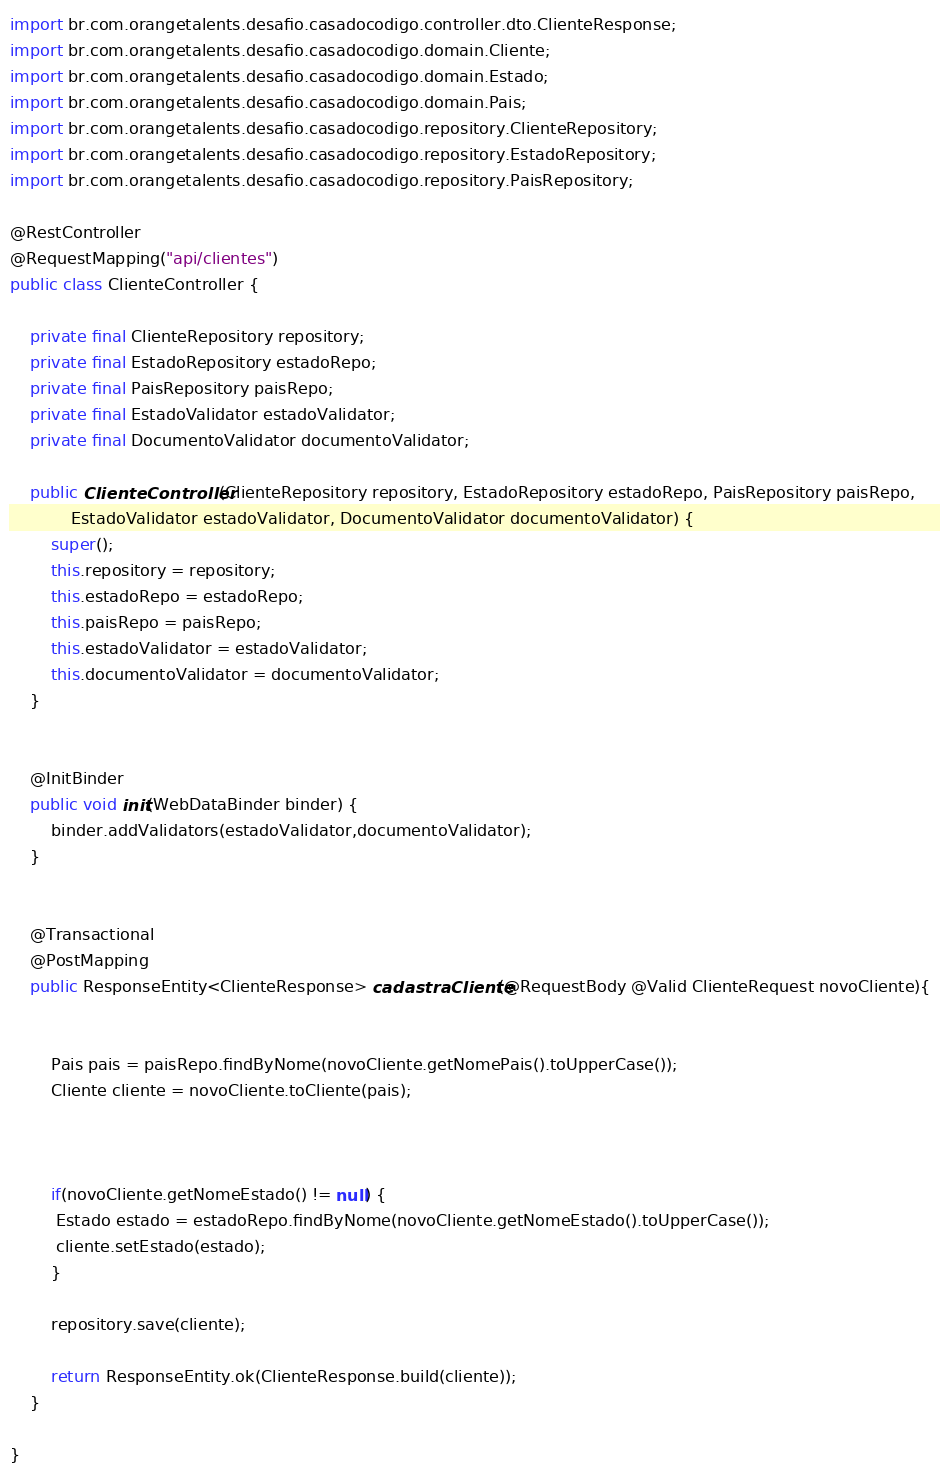<code> <loc_0><loc_0><loc_500><loc_500><_Java_>import br.com.orangetalents.desafio.casadocodigo.controller.dto.ClienteResponse;
import br.com.orangetalents.desafio.casadocodigo.domain.Cliente;
import br.com.orangetalents.desafio.casadocodigo.domain.Estado;
import br.com.orangetalents.desafio.casadocodigo.domain.Pais;
import br.com.orangetalents.desafio.casadocodigo.repository.ClienteRepository;
import br.com.orangetalents.desafio.casadocodigo.repository.EstadoRepository;
import br.com.orangetalents.desafio.casadocodigo.repository.PaisRepository;

@RestController
@RequestMapping("api/clientes")
public class ClienteController {

	private final ClienteRepository repository;
	private final EstadoRepository estadoRepo;
	private final PaisRepository paisRepo;
	private final EstadoValidator estadoValidator;
	private final DocumentoValidator documentoValidator;
	
	public ClienteController(ClienteRepository repository, EstadoRepository estadoRepo, PaisRepository paisRepo,
			EstadoValidator estadoValidator, DocumentoValidator documentoValidator) {
		super();
		this.repository = repository;
		this.estadoRepo = estadoRepo;
		this.paisRepo = paisRepo;
		this.estadoValidator = estadoValidator;
		this.documentoValidator = documentoValidator;
	}


	@InitBinder
	public void init(WebDataBinder binder) {
		binder.addValidators(estadoValidator,documentoValidator);
	}
	
	
	@Transactional
	@PostMapping
	public ResponseEntity<ClienteResponse> cadastraCliente(@RequestBody @Valid ClienteRequest novoCliente){

		
		Pais pais = paisRepo.findByNome(novoCliente.getNomePais().toUpperCase());
		Cliente cliente = novoCliente.toCliente(pais);
		
		
		
		if(novoCliente.getNomeEstado() != null) {
		 Estado estado = estadoRepo.findByNome(novoCliente.getNomeEstado().toUpperCase());
		 cliente.setEstado(estado);		 
		}
		
		repository.save(cliente);
		
		return ResponseEntity.ok(ClienteResponse.build(cliente));
	}	
	
}
</code> 